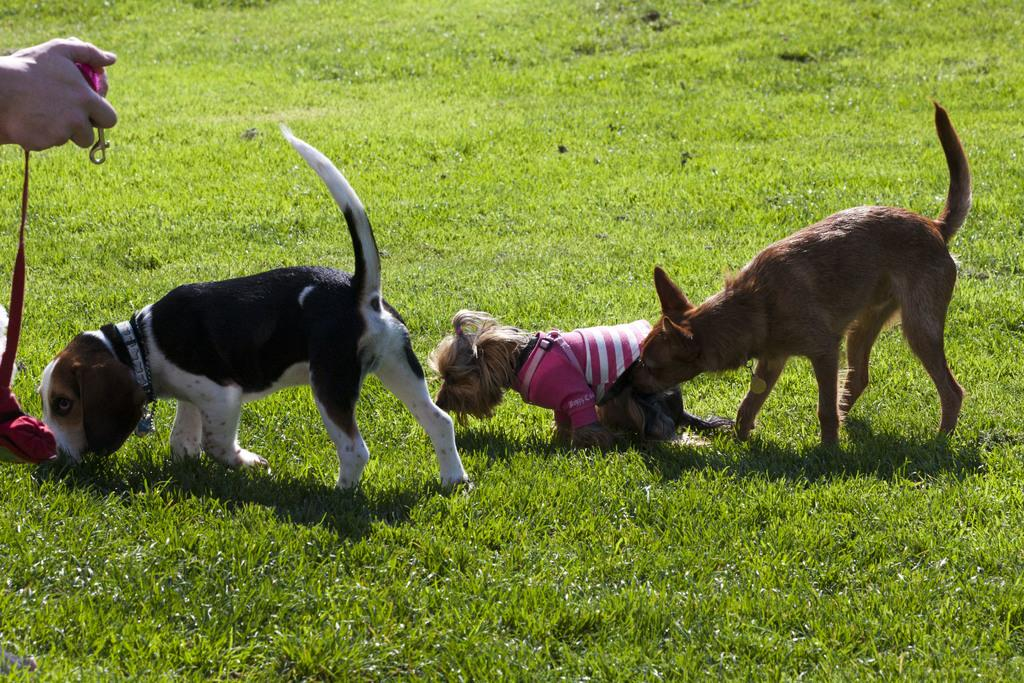How many dogs are present in the image? There are two dogs in the image. Can you describe the appearance of one of the dogs? One of the dogs is wearing a shirt. What can be seen in the background of the image? There is grass visible in the background of the image. What is the person on the left side of the image holding? The person on the left side of the image is holding a belt. What type of approval is the dog seeking from the person holding the belt? There is no indication in the image that the dog is seeking any type of approval from the person holding the belt. 